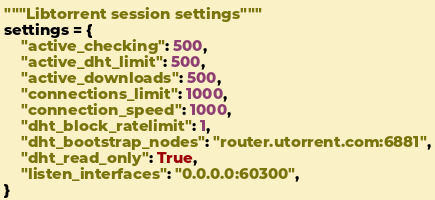<code> <loc_0><loc_0><loc_500><loc_500><_Python_>"""Libtorrent session settings"""
settings = {
    "active_checking": 500,
    "active_dht_limit": 500,
    "active_downloads": 500,
    "connections_limit": 1000,
    "connection_speed": 1000,
    "dht_block_ratelimit": 1,
    "dht_bootstrap_nodes": "router.utorrent.com:6881",
    "dht_read_only": True,
    "listen_interfaces": "0.0.0.0:60300",
}
</code> 